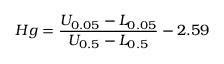Convert formula to latex. <formula><loc_0><loc_0><loc_500><loc_500>H g = \frac { U _ { 0 . 0 5 } - L _ { 0 . 0 5 } } { U _ { 0 . 5 } - L _ { 0 . 5 } } - 2 . 5 9</formula> 